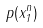Convert formula to latex. <formula><loc_0><loc_0><loc_500><loc_500>p ( x _ { 1 } ^ { n } )</formula> 